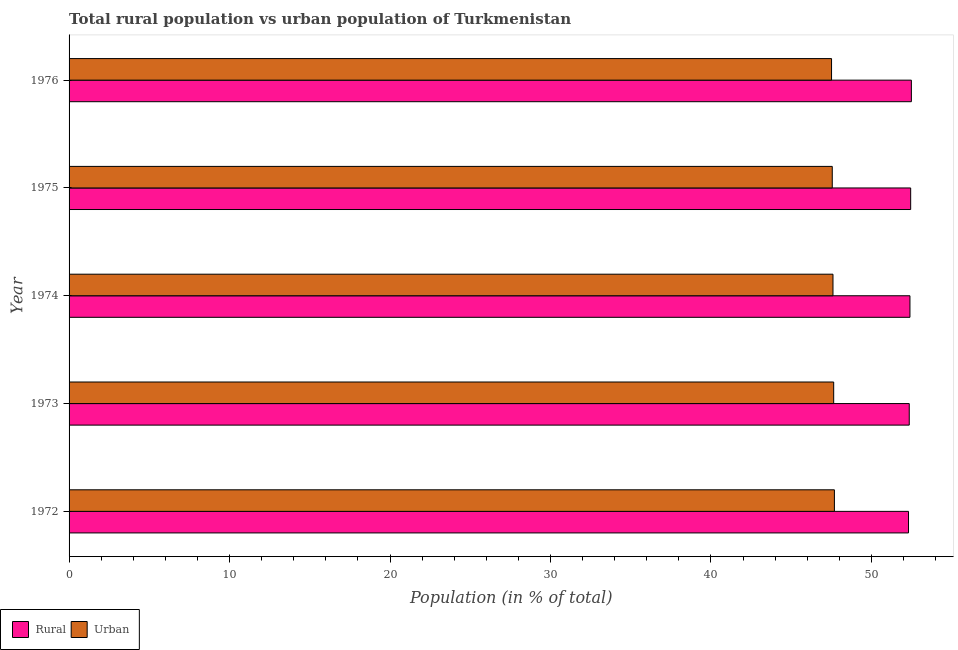How many groups of bars are there?
Provide a short and direct response. 5. How many bars are there on the 5th tick from the top?
Your response must be concise. 2. What is the label of the 3rd group of bars from the top?
Your response must be concise. 1974. In how many cases, is the number of bars for a given year not equal to the number of legend labels?
Ensure brevity in your answer.  0. What is the urban population in 1975?
Make the answer very short. 47.56. Across all years, what is the maximum urban population?
Your answer should be compact. 47.69. Across all years, what is the minimum rural population?
Your answer should be very brief. 52.31. In which year was the urban population minimum?
Provide a short and direct response. 1976. What is the total rural population in the graph?
Give a very brief answer. 261.99. What is the difference between the rural population in 1972 and that in 1976?
Give a very brief answer. -0.18. What is the difference between the urban population in 1975 and the rural population in 1974?
Offer a very short reply. -4.84. What is the average urban population per year?
Offer a very short reply. 47.6. In the year 1972, what is the difference between the urban population and rural population?
Provide a succinct answer. -4.62. In how many years, is the rural population greater than 16 %?
Your answer should be compact. 5. What is the difference between the highest and the second highest rural population?
Ensure brevity in your answer.  0.04. What is the difference between the highest and the lowest rural population?
Provide a short and direct response. 0.18. What does the 2nd bar from the top in 1976 represents?
Your response must be concise. Rural. What does the 1st bar from the bottom in 1975 represents?
Give a very brief answer. Rural. What is the difference between two consecutive major ticks on the X-axis?
Ensure brevity in your answer.  10. Are the values on the major ticks of X-axis written in scientific E-notation?
Offer a very short reply. No. Where does the legend appear in the graph?
Provide a short and direct response. Bottom left. How are the legend labels stacked?
Ensure brevity in your answer.  Horizontal. What is the title of the graph?
Your answer should be compact. Total rural population vs urban population of Turkmenistan. Does "From production" appear as one of the legend labels in the graph?
Ensure brevity in your answer.  No. What is the label or title of the X-axis?
Provide a succinct answer. Population (in % of total). What is the label or title of the Y-axis?
Your response must be concise. Year. What is the Population (in % of total) of Rural in 1972?
Offer a very short reply. 52.31. What is the Population (in % of total) in Urban in 1972?
Ensure brevity in your answer.  47.69. What is the Population (in % of total) of Rural in 1973?
Offer a very short reply. 52.35. What is the Population (in % of total) in Urban in 1973?
Provide a succinct answer. 47.65. What is the Population (in % of total) of Rural in 1974?
Your response must be concise. 52.4. What is the Population (in % of total) in Urban in 1974?
Offer a very short reply. 47.6. What is the Population (in % of total) of Rural in 1975?
Your answer should be very brief. 52.44. What is the Population (in % of total) of Urban in 1975?
Offer a very short reply. 47.56. What is the Population (in % of total) in Rural in 1976?
Your answer should be very brief. 52.49. What is the Population (in % of total) of Urban in 1976?
Your response must be concise. 47.51. Across all years, what is the maximum Population (in % of total) in Rural?
Give a very brief answer. 52.49. Across all years, what is the maximum Population (in % of total) in Urban?
Your answer should be very brief. 47.69. Across all years, what is the minimum Population (in % of total) of Rural?
Give a very brief answer. 52.31. Across all years, what is the minimum Population (in % of total) of Urban?
Provide a short and direct response. 47.51. What is the total Population (in % of total) of Rural in the graph?
Your answer should be compact. 261.99. What is the total Population (in % of total) of Urban in the graph?
Offer a terse response. 238.01. What is the difference between the Population (in % of total) in Rural in 1972 and that in 1973?
Make the answer very short. -0.04. What is the difference between the Population (in % of total) of Urban in 1972 and that in 1973?
Ensure brevity in your answer.  0.04. What is the difference between the Population (in % of total) in Rural in 1972 and that in 1974?
Make the answer very short. -0.09. What is the difference between the Population (in % of total) of Urban in 1972 and that in 1974?
Provide a short and direct response. 0.09. What is the difference between the Population (in % of total) in Rural in 1972 and that in 1975?
Offer a very short reply. -0.13. What is the difference between the Population (in % of total) in Urban in 1972 and that in 1975?
Ensure brevity in your answer.  0.13. What is the difference between the Population (in % of total) of Rural in 1972 and that in 1976?
Keep it short and to the point. -0.18. What is the difference between the Population (in % of total) of Urban in 1972 and that in 1976?
Provide a succinct answer. 0.18. What is the difference between the Population (in % of total) in Rural in 1973 and that in 1974?
Make the answer very short. -0.04. What is the difference between the Population (in % of total) of Urban in 1973 and that in 1974?
Ensure brevity in your answer.  0.04. What is the difference between the Population (in % of total) in Rural in 1973 and that in 1975?
Keep it short and to the point. -0.09. What is the difference between the Population (in % of total) of Urban in 1973 and that in 1975?
Provide a succinct answer. 0.09. What is the difference between the Population (in % of total) in Rural in 1973 and that in 1976?
Offer a very short reply. -0.13. What is the difference between the Population (in % of total) of Urban in 1973 and that in 1976?
Keep it short and to the point. 0.13. What is the difference between the Population (in % of total) of Rural in 1974 and that in 1975?
Your answer should be very brief. -0.04. What is the difference between the Population (in % of total) of Urban in 1974 and that in 1975?
Your answer should be compact. 0.04. What is the difference between the Population (in % of total) of Rural in 1974 and that in 1976?
Give a very brief answer. -0.09. What is the difference between the Population (in % of total) in Urban in 1974 and that in 1976?
Your response must be concise. 0.09. What is the difference between the Population (in % of total) of Rural in 1975 and that in 1976?
Your answer should be very brief. -0.04. What is the difference between the Population (in % of total) of Urban in 1975 and that in 1976?
Provide a short and direct response. 0.04. What is the difference between the Population (in % of total) of Rural in 1972 and the Population (in % of total) of Urban in 1973?
Your answer should be compact. 4.66. What is the difference between the Population (in % of total) in Rural in 1972 and the Population (in % of total) in Urban in 1974?
Provide a short and direct response. 4.71. What is the difference between the Population (in % of total) of Rural in 1972 and the Population (in % of total) of Urban in 1975?
Provide a short and direct response. 4.75. What is the difference between the Population (in % of total) in Rural in 1972 and the Population (in % of total) in Urban in 1976?
Offer a terse response. 4.8. What is the difference between the Population (in % of total) of Rural in 1973 and the Population (in % of total) of Urban in 1974?
Your answer should be very brief. 4.75. What is the difference between the Population (in % of total) of Rural in 1973 and the Population (in % of total) of Urban in 1975?
Your response must be concise. 4.8. What is the difference between the Population (in % of total) in Rural in 1973 and the Population (in % of total) in Urban in 1976?
Offer a terse response. 4.84. What is the difference between the Population (in % of total) of Rural in 1974 and the Population (in % of total) of Urban in 1975?
Provide a succinct answer. 4.84. What is the difference between the Population (in % of total) in Rural in 1974 and the Population (in % of total) in Urban in 1976?
Offer a very short reply. 4.88. What is the difference between the Population (in % of total) of Rural in 1975 and the Population (in % of total) of Urban in 1976?
Your response must be concise. 4.93. What is the average Population (in % of total) in Rural per year?
Your response must be concise. 52.4. What is the average Population (in % of total) in Urban per year?
Provide a succinct answer. 47.6. In the year 1972, what is the difference between the Population (in % of total) of Rural and Population (in % of total) of Urban?
Provide a short and direct response. 4.62. In the year 1973, what is the difference between the Population (in % of total) in Rural and Population (in % of total) in Urban?
Your response must be concise. 4.71. In the year 1974, what is the difference between the Population (in % of total) in Rural and Population (in % of total) in Urban?
Offer a very short reply. 4.8. In the year 1975, what is the difference between the Population (in % of total) in Rural and Population (in % of total) in Urban?
Provide a short and direct response. 4.89. In the year 1976, what is the difference between the Population (in % of total) in Rural and Population (in % of total) in Urban?
Make the answer very short. 4.97. What is the ratio of the Population (in % of total) in Rural in 1972 to that in 1973?
Ensure brevity in your answer.  1. What is the ratio of the Population (in % of total) of Rural in 1972 to that in 1974?
Offer a very short reply. 1. What is the ratio of the Population (in % of total) in Urban in 1972 to that in 1974?
Your response must be concise. 1. What is the ratio of the Population (in % of total) of Urban in 1973 to that in 1974?
Provide a short and direct response. 1. What is the ratio of the Population (in % of total) of Urban in 1973 to that in 1975?
Your answer should be compact. 1. What is the ratio of the Population (in % of total) in Urban in 1973 to that in 1976?
Make the answer very short. 1. What is the ratio of the Population (in % of total) of Rural in 1974 to that in 1975?
Give a very brief answer. 1. What is the ratio of the Population (in % of total) of Urban in 1974 to that in 1975?
Make the answer very short. 1. What is the ratio of the Population (in % of total) of Rural in 1975 to that in 1976?
Your answer should be compact. 1. What is the difference between the highest and the second highest Population (in % of total) in Rural?
Provide a short and direct response. 0.04. What is the difference between the highest and the second highest Population (in % of total) of Urban?
Offer a very short reply. 0.04. What is the difference between the highest and the lowest Population (in % of total) in Rural?
Offer a very short reply. 0.18. What is the difference between the highest and the lowest Population (in % of total) in Urban?
Your answer should be compact. 0.18. 